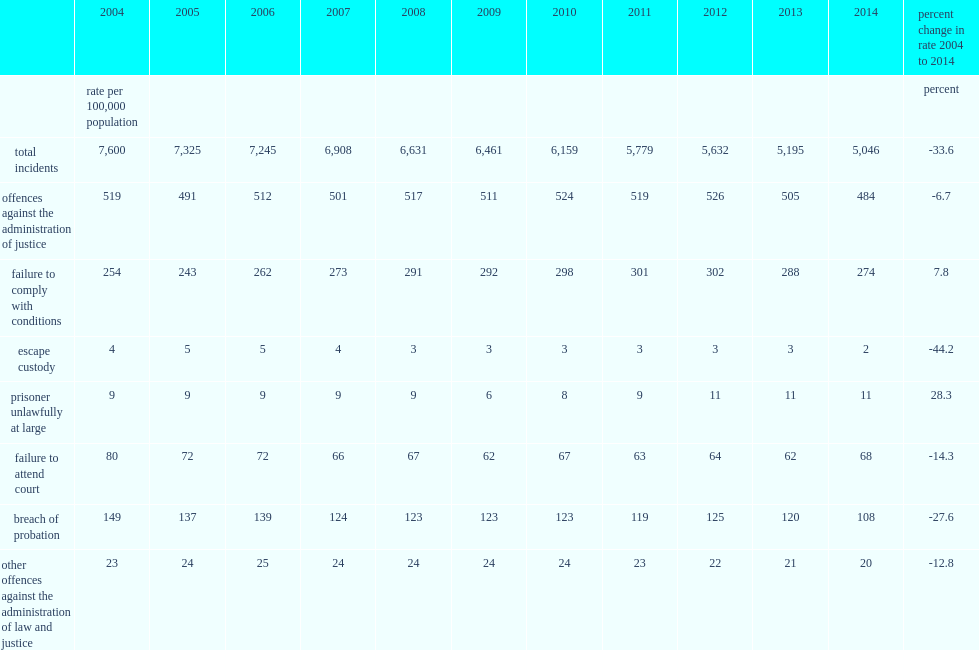In 2014, what is the percentage of incidents of offences against the administration of justice of all criminal code violations (excluding traffic) reported by police? 0.095918. 